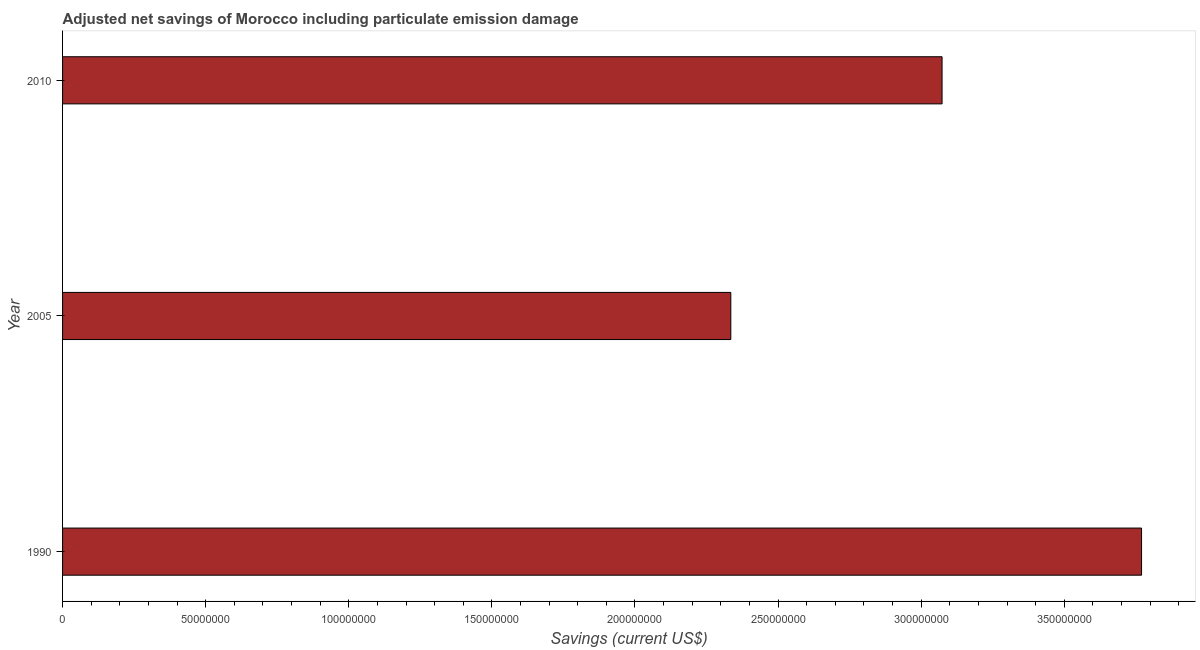What is the title of the graph?
Provide a short and direct response. Adjusted net savings of Morocco including particulate emission damage. What is the label or title of the X-axis?
Offer a very short reply. Savings (current US$). What is the label or title of the Y-axis?
Your answer should be compact. Year. What is the adjusted net savings in 2010?
Provide a short and direct response. 3.07e+08. Across all years, what is the maximum adjusted net savings?
Provide a short and direct response. 3.77e+08. Across all years, what is the minimum adjusted net savings?
Give a very brief answer. 2.33e+08. What is the sum of the adjusted net savings?
Offer a terse response. 9.18e+08. What is the difference between the adjusted net savings in 2005 and 2010?
Keep it short and to the point. -7.38e+07. What is the average adjusted net savings per year?
Your answer should be very brief. 3.06e+08. What is the median adjusted net savings?
Give a very brief answer. 3.07e+08. What is the ratio of the adjusted net savings in 1990 to that in 2005?
Give a very brief answer. 1.61. Is the adjusted net savings in 2005 less than that in 2010?
Offer a terse response. Yes. Is the difference between the adjusted net savings in 1990 and 2010 greater than the difference between any two years?
Keep it short and to the point. No. What is the difference between the highest and the second highest adjusted net savings?
Give a very brief answer. 6.97e+07. Is the sum of the adjusted net savings in 1990 and 2005 greater than the maximum adjusted net savings across all years?
Provide a succinct answer. Yes. What is the difference between the highest and the lowest adjusted net savings?
Offer a very short reply. 1.44e+08. What is the difference between two consecutive major ticks on the X-axis?
Your answer should be very brief. 5.00e+07. Are the values on the major ticks of X-axis written in scientific E-notation?
Your response must be concise. No. What is the Savings (current US$) in 1990?
Your response must be concise. 3.77e+08. What is the Savings (current US$) of 2005?
Provide a short and direct response. 2.33e+08. What is the Savings (current US$) of 2010?
Your answer should be very brief. 3.07e+08. What is the difference between the Savings (current US$) in 1990 and 2005?
Ensure brevity in your answer.  1.44e+08. What is the difference between the Savings (current US$) in 1990 and 2010?
Make the answer very short. 6.97e+07. What is the difference between the Savings (current US$) in 2005 and 2010?
Your answer should be compact. -7.38e+07. What is the ratio of the Savings (current US$) in 1990 to that in 2005?
Your answer should be very brief. 1.61. What is the ratio of the Savings (current US$) in 1990 to that in 2010?
Ensure brevity in your answer.  1.23. What is the ratio of the Savings (current US$) in 2005 to that in 2010?
Your response must be concise. 0.76. 